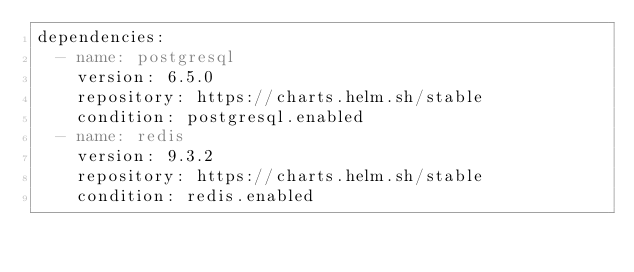Convert code to text. <code><loc_0><loc_0><loc_500><loc_500><_YAML_>dependencies:
  - name: postgresql
    version: 6.5.0
    repository: https://charts.helm.sh/stable
    condition: postgresql.enabled
  - name: redis
    version: 9.3.2
    repository: https://charts.helm.sh/stable
    condition: redis.enabled
</code> 